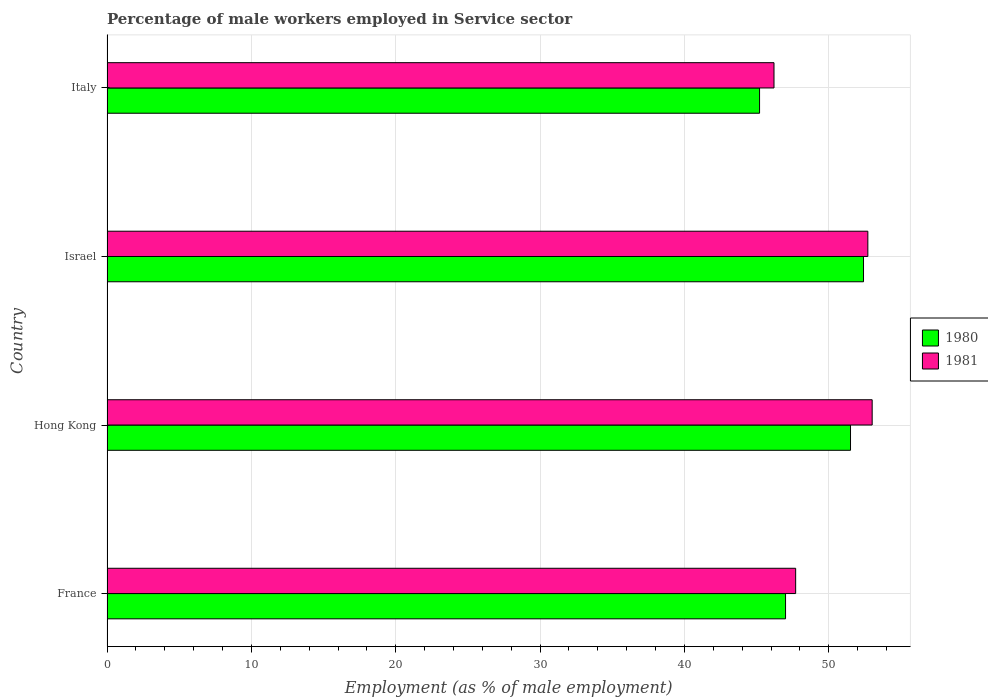How many different coloured bars are there?
Keep it short and to the point. 2. How many groups of bars are there?
Keep it short and to the point. 4. Are the number of bars on each tick of the Y-axis equal?
Ensure brevity in your answer.  Yes. How many bars are there on the 1st tick from the bottom?
Offer a very short reply. 2. In how many cases, is the number of bars for a given country not equal to the number of legend labels?
Offer a terse response. 0. What is the percentage of male workers employed in Service sector in 1980 in Israel?
Your answer should be very brief. 52.4. Across all countries, what is the maximum percentage of male workers employed in Service sector in 1980?
Offer a terse response. 52.4. Across all countries, what is the minimum percentage of male workers employed in Service sector in 1981?
Give a very brief answer. 46.2. In which country was the percentage of male workers employed in Service sector in 1980 maximum?
Your answer should be very brief. Israel. In which country was the percentage of male workers employed in Service sector in 1981 minimum?
Give a very brief answer. Italy. What is the total percentage of male workers employed in Service sector in 1980 in the graph?
Ensure brevity in your answer.  196.1. What is the difference between the percentage of male workers employed in Service sector in 1980 in France and that in Israel?
Provide a succinct answer. -5.4. What is the difference between the percentage of male workers employed in Service sector in 1981 in Hong Kong and the percentage of male workers employed in Service sector in 1980 in France?
Provide a short and direct response. 6. What is the average percentage of male workers employed in Service sector in 1980 per country?
Give a very brief answer. 49.03. In how many countries, is the percentage of male workers employed in Service sector in 1980 greater than 24 %?
Offer a very short reply. 4. What is the ratio of the percentage of male workers employed in Service sector in 1981 in Hong Kong to that in Italy?
Provide a succinct answer. 1.15. Is the difference between the percentage of male workers employed in Service sector in 1981 in France and Hong Kong greater than the difference between the percentage of male workers employed in Service sector in 1980 in France and Hong Kong?
Your answer should be very brief. No. What is the difference between the highest and the second highest percentage of male workers employed in Service sector in 1981?
Your answer should be compact. 0.3. What is the difference between the highest and the lowest percentage of male workers employed in Service sector in 1980?
Ensure brevity in your answer.  7.2. In how many countries, is the percentage of male workers employed in Service sector in 1980 greater than the average percentage of male workers employed in Service sector in 1980 taken over all countries?
Make the answer very short. 2. What does the 2nd bar from the top in Israel represents?
Give a very brief answer. 1980. Are all the bars in the graph horizontal?
Provide a succinct answer. Yes. What is the difference between two consecutive major ticks on the X-axis?
Your answer should be very brief. 10. How are the legend labels stacked?
Offer a very short reply. Vertical. What is the title of the graph?
Provide a short and direct response. Percentage of male workers employed in Service sector. What is the label or title of the X-axis?
Offer a terse response. Employment (as % of male employment). What is the Employment (as % of male employment) of 1980 in France?
Make the answer very short. 47. What is the Employment (as % of male employment) of 1981 in France?
Your answer should be compact. 47.7. What is the Employment (as % of male employment) in 1980 in Hong Kong?
Your answer should be compact. 51.5. What is the Employment (as % of male employment) of 1981 in Hong Kong?
Your answer should be very brief. 53. What is the Employment (as % of male employment) in 1980 in Israel?
Provide a short and direct response. 52.4. What is the Employment (as % of male employment) in 1981 in Israel?
Your answer should be very brief. 52.7. What is the Employment (as % of male employment) of 1980 in Italy?
Provide a short and direct response. 45.2. What is the Employment (as % of male employment) of 1981 in Italy?
Provide a short and direct response. 46.2. Across all countries, what is the maximum Employment (as % of male employment) of 1980?
Your answer should be compact. 52.4. Across all countries, what is the maximum Employment (as % of male employment) in 1981?
Make the answer very short. 53. Across all countries, what is the minimum Employment (as % of male employment) in 1980?
Provide a short and direct response. 45.2. Across all countries, what is the minimum Employment (as % of male employment) of 1981?
Provide a short and direct response. 46.2. What is the total Employment (as % of male employment) in 1980 in the graph?
Keep it short and to the point. 196.1. What is the total Employment (as % of male employment) in 1981 in the graph?
Your answer should be very brief. 199.6. What is the difference between the Employment (as % of male employment) in 1981 in France and that in Israel?
Provide a short and direct response. -5. What is the difference between the Employment (as % of male employment) of 1980 in France and that in Italy?
Keep it short and to the point. 1.8. What is the difference between the Employment (as % of male employment) in 1981 in France and that in Italy?
Provide a succinct answer. 1.5. What is the difference between the Employment (as % of male employment) of 1980 in Hong Kong and that in Israel?
Your response must be concise. -0.9. What is the difference between the Employment (as % of male employment) of 1980 in Hong Kong and that in Italy?
Provide a succinct answer. 6.3. What is the difference between the Employment (as % of male employment) of 1980 in Hong Kong and the Employment (as % of male employment) of 1981 in Italy?
Your response must be concise. 5.3. What is the average Employment (as % of male employment) in 1980 per country?
Your answer should be compact. 49.02. What is the average Employment (as % of male employment) of 1981 per country?
Offer a terse response. 49.9. What is the difference between the Employment (as % of male employment) of 1980 and Employment (as % of male employment) of 1981 in Hong Kong?
Offer a terse response. -1.5. What is the ratio of the Employment (as % of male employment) of 1980 in France to that in Hong Kong?
Provide a succinct answer. 0.91. What is the ratio of the Employment (as % of male employment) of 1980 in France to that in Israel?
Your response must be concise. 0.9. What is the ratio of the Employment (as % of male employment) of 1981 in France to that in Israel?
Your response must be concise. 0.91. What is the ratio of the Employment (as % of male employment) in 1980 in France to that in Italy?
Provide a succinct answer. 1.04. What is the ratio of the Employment (as % of male employment) in 1981 in France to that in Italy?
Your answer should be compact. 1.03. What is the ratio of the Employment (as % of male employment) in 1980 in Hong Kong to that in Israel?
Keep it short and to the point. 0.98. What is the ratio of the Employment (as % of male employment) of 1981 in Hong Kong to that in Israel?
Your response must be concise. 1.01. What is the ratio of the Employment (as % of male employment) in 1980 in Hong Kong to that in Italy?
Offer a very short reply. 1.14. What is the ratio of the Employment (as % of male employment) of 1981 in Hong Kong to that in Italy?
Offer a terse response. 1.15. What is the ratio of the Employment (as % of male employment) in 1980 in Israel to that in Italy?
Provide a succinct answer. 1.16. What is the ratio of the Employment (as % of male employment) of 1981 in Israel to that in Italy?
Offer a very short reply. 1.14. What is the difference between the highest and the second highest Employment (as % of male employment) in 1980?
Ensure brevity in your answer.  0.9. What is the difference between the highest and the second highest Employment (as % of male employment) of 1981?
Your response must be concise. 0.3. 